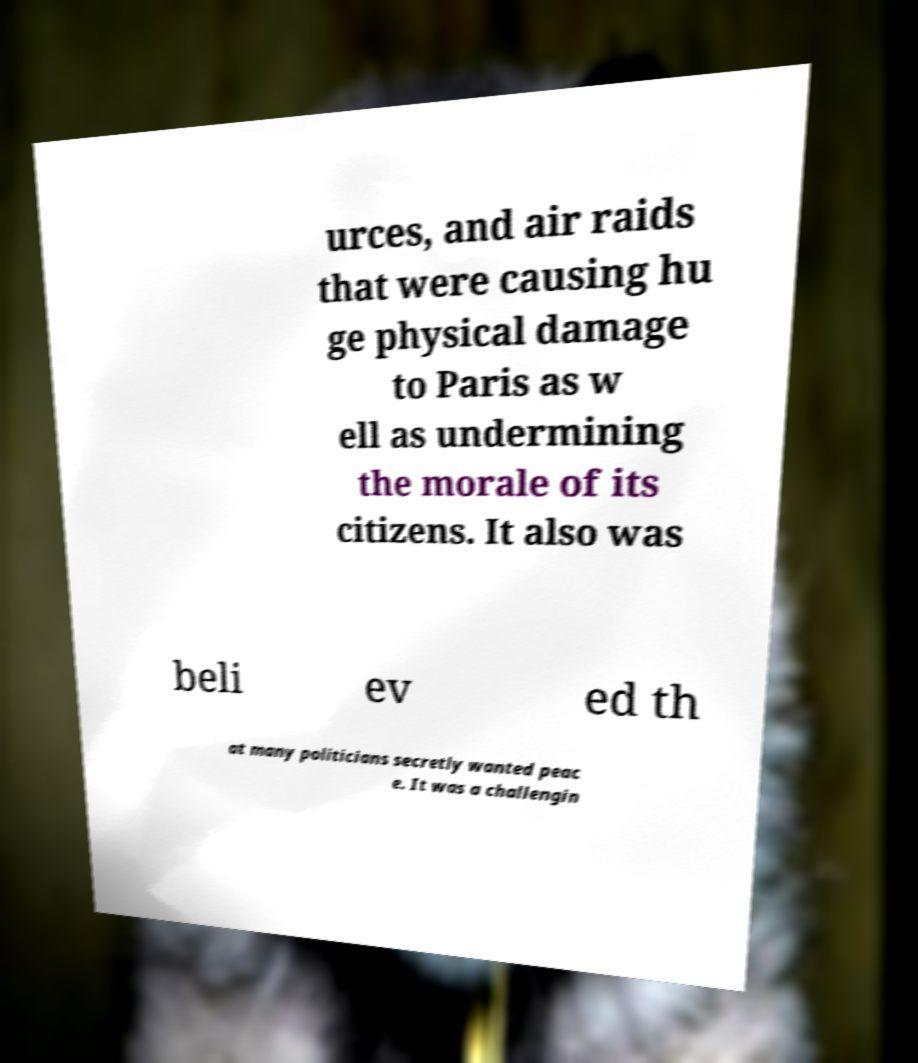I need the written content from this picture converted into text. Can you do that? urces, and air raids that were causing hu ge physical damage to Paris as w ell as undermining the morale of its citizens. It also was beli ev ed th at many politicians secretly wanted peac e. It was a challengin 